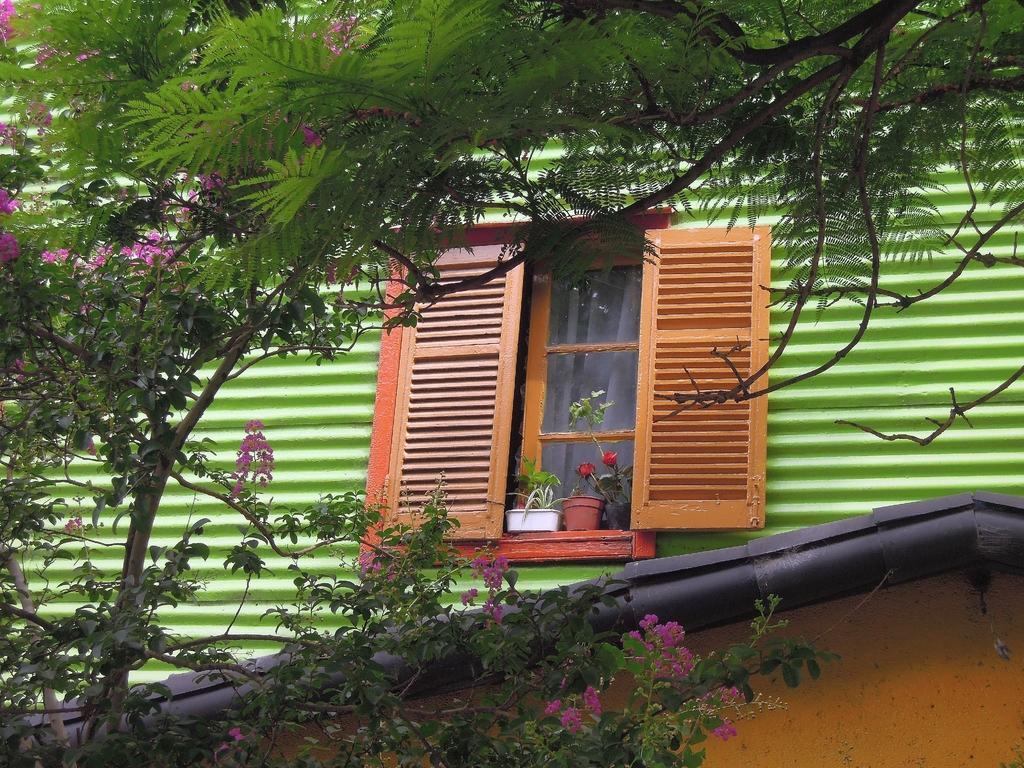Describe this image in one or two sentences. In this image there is a wall of a house. There is a wooden window to the wall of the house. Near the window there are flower pots. There is a curtain to the window. In the foreground there is a tree. There are leaves and flowers to the tree. 